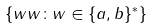Convert formula to latex. <formula><loc_0><loc_0><loc_500><loc_500>\{ w w \colon w \in \{ a , b \} ^ { * } \}</formula> 